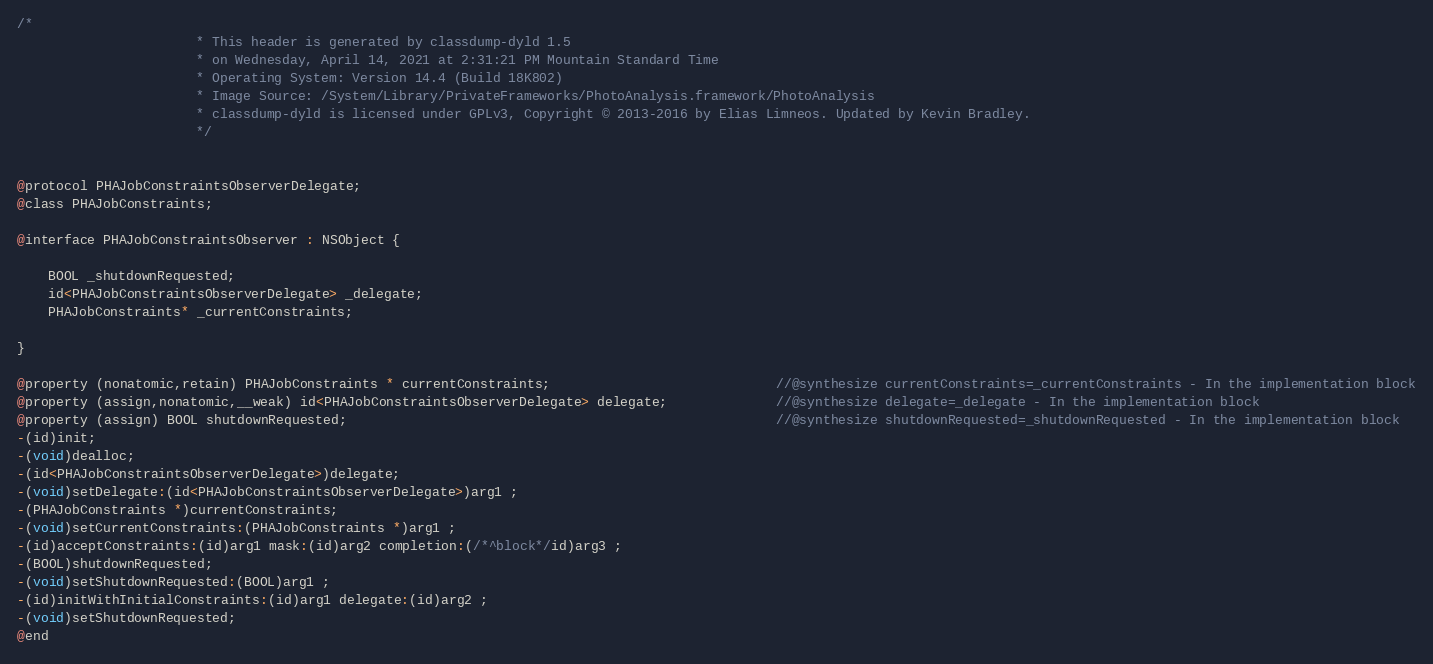Convert code to text. <code><loc_0><loc_0><loc_500><loc_500><_C_>/*
                       * This header is generated by classdump-dyld 1.5
                       * on Wednesday, April 14, 2021 at 2:31:21 PM Mountain Standard Time
                       * Operating System: Version 14.4 (Build 18K802)
                       * Image Source: /System/Library/PrivateFrameworks/PhotoAnalysis.framework/PhotoAnalysis
                       * classdump-dyld is licensed under GPLv3, Copyright © 2013-2016 by Elias Limneos. Updated by Kevin Bradley.
                       */


@protocol PHAJobConstraintsObserverDelegate;
@class PHAJobConstraints;

@interface PHAJobConstraintsObserver : NSObject {

	BOOL _shutdownRequested;
	id<PHAJobConstraintsObserverDelegate> _delegate;
	PHAJobConstraints* _currentConstraints;

}

@property (nonatomic,retain) PHAJobConstraints * currentConstraints;                             //@synthesize currentConstraints=_currentConstraints - In the implementation block
@property (assign,nonatomic,__weak) id<PHAJobConstraintsObserverDelegate> delegate;              //@synthesize delegate=_delegate - In the implementation block
@property (assign) BOOL shutdownRequested;                                                       //@synthesize shutdownRequested=_shutdownRequested - In the implementation block
-(id)init;
-(void)dealloc;
-(id<PHAJobConstraintsObserverDelegate>)delegate;
-(void)setDelegate:(id<PHAJobConstraintsObserverDelegate>)arg1 ;
-(PHAJobConstraints *)currentConstraints;
-(void)setCurrentConstraints:(PHAJobConstraints *)arg1 ;
-(id)acceptConstraints:(id)arg1 mask:(id)arg2 completion:(/*^block*/id)arg3 ;
-(BOOL)shutdownRequested;
-(void)setShutdownRequested:(BOOL)arg1 ;
-(id)initWithInitialConstraints:(id)arg1 delegate:(id)arg2 ;
-(void)setShutdownRequested;
@end

</code> 